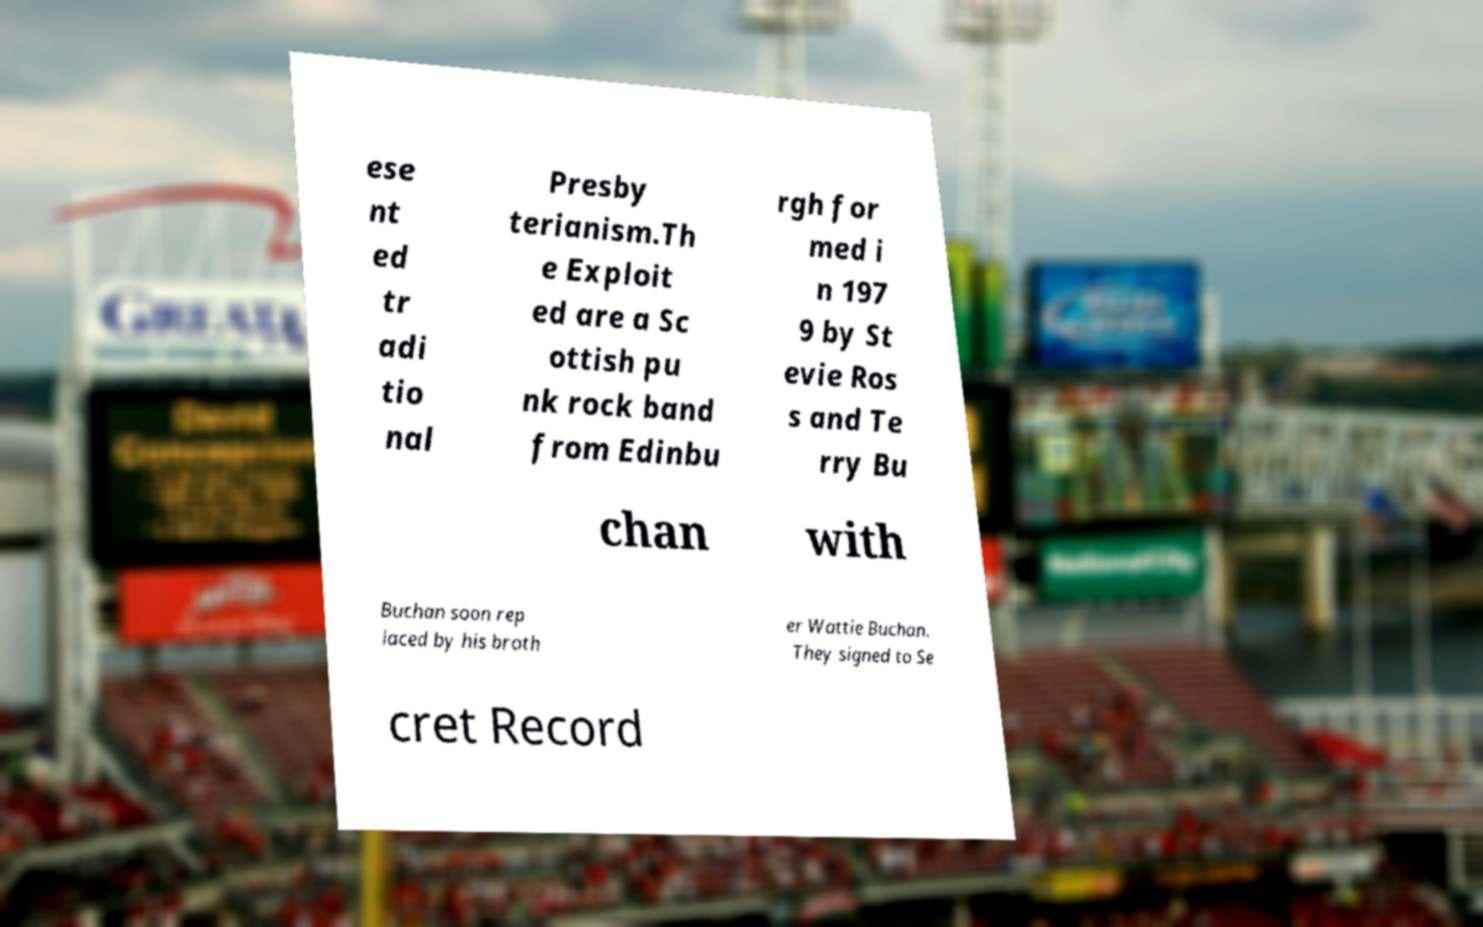Can you accurately transcribe the text from the provided image for me? ese nt ed tr adi tio nal Presby terianism.Th e Exploit ed are a Sc ottish pu nk rock band from Edinbu rgh for med i n 197 9 by St evie Ros s and Te rry Bu chan with Buchan soon rep laced by his broth er Wattie Buchan. They signed to Se cret Record 